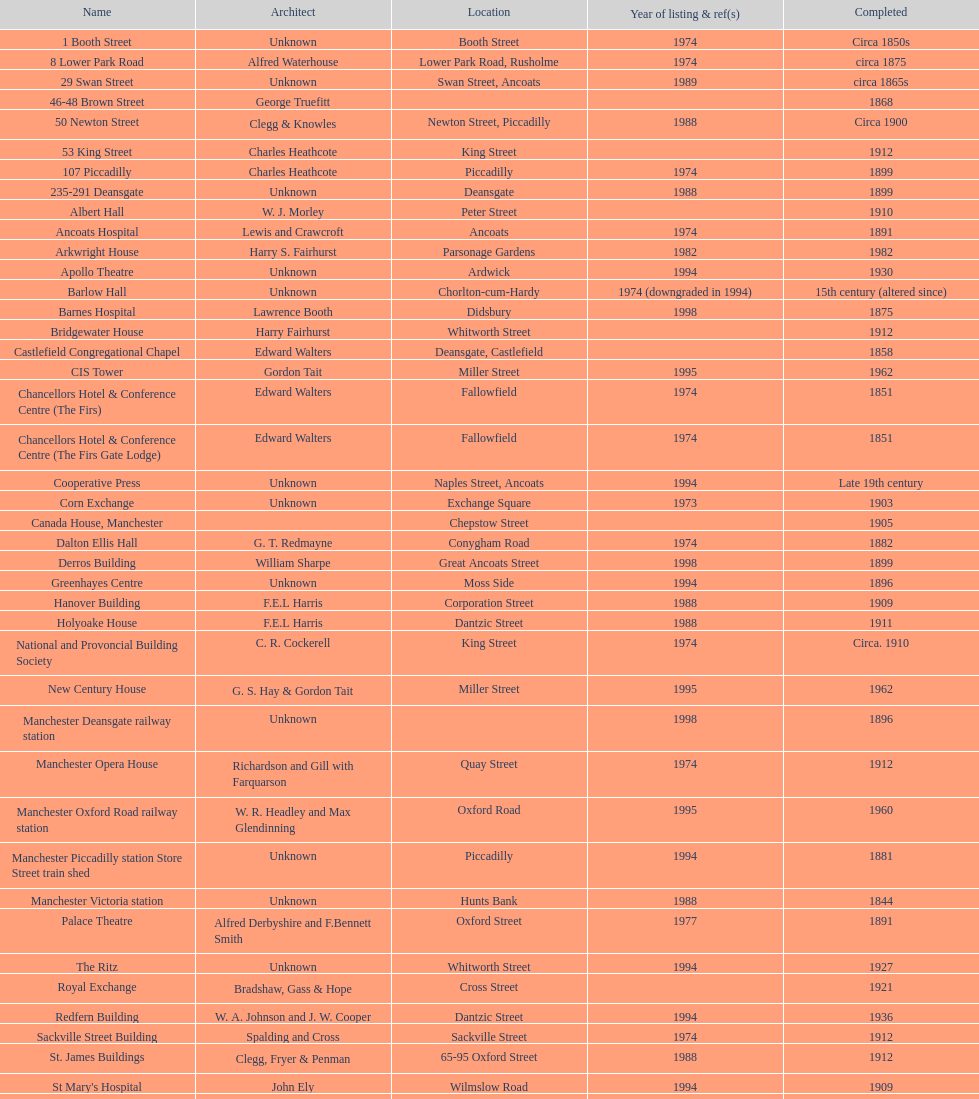What is the difference, in years, between the completion dates of 53 king street and castlefield congregational chapel? 54 years. 